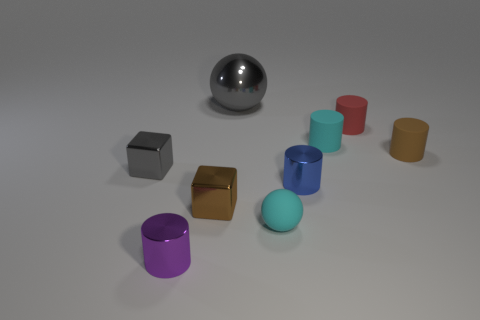Subtract all red cylinders. How many cylinders are left? 4 Subtract all brown cylinders. How many cylinders are left? 4 Add 1 cyan matte balls. How many objects exist? 10 Subtract 3 cylinders. How many cylinders are left? 2 Subtract all balls. How many objects are left? 7 Add 6 small brown matte cubes. How many small brown matte cubes exist? 6 Subtract 1 gray spheres. How many objects are left? 8 Subtract all brown cylinders. Subtract all blue blocks. How many cylinders are left? 4 Subtract all small cyan balls. Subtract all metallic blocks. How many objects are left? 6 Add 3 cyan cylinders. How many cyan cylinders are left? 4 